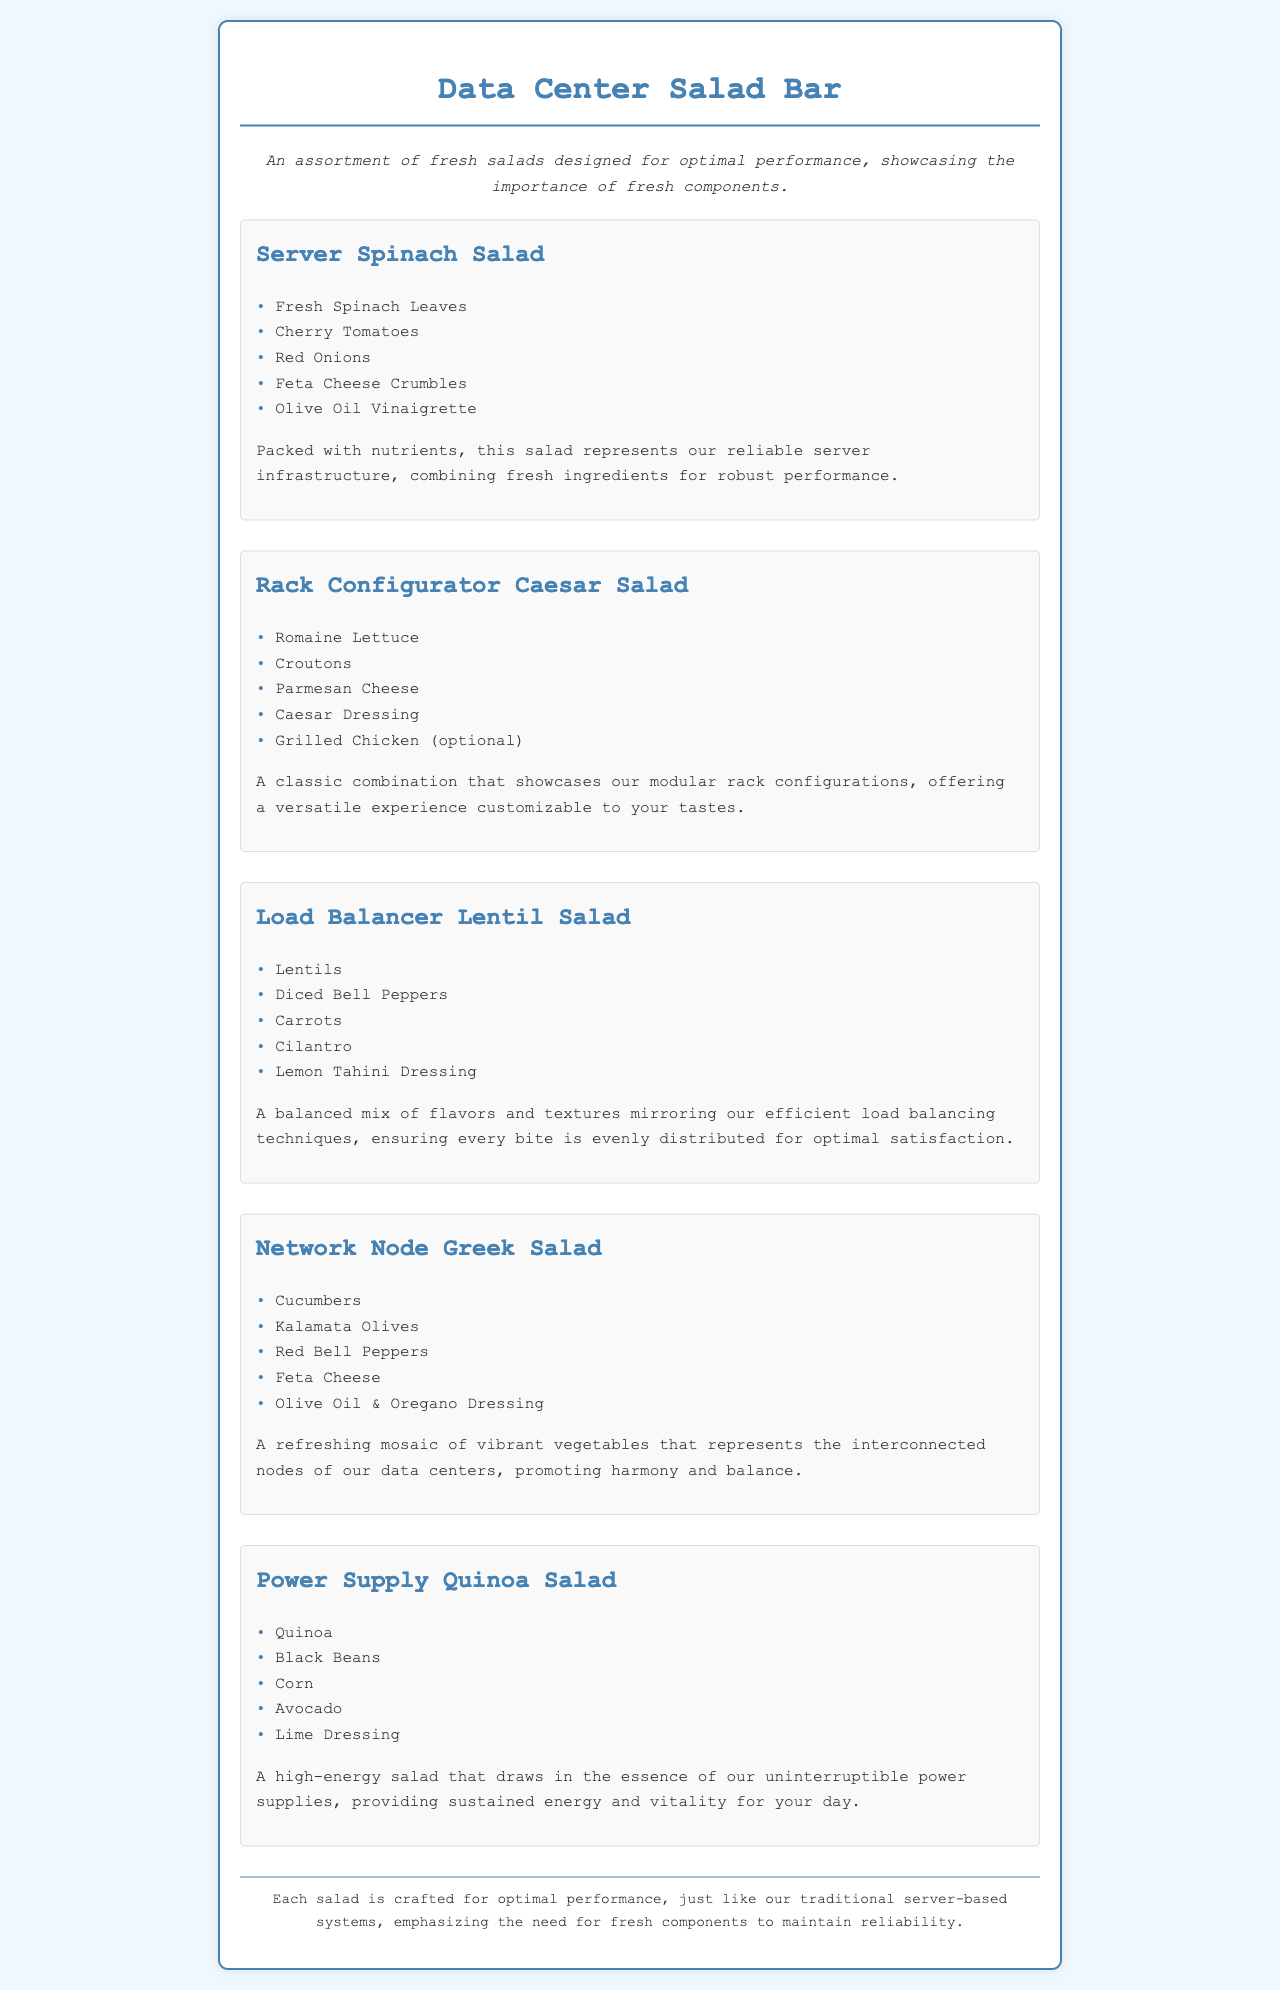What is the name of the first salad? The first salad listed in the document is the "Server Spinach Salad".
Answer: Server Spinach Salad How many salads are featured in the menu? The document includes a total of five salads.
Answer: Five What dressing is used in the Load Balancer Lentil Salad? The dressing mentioned for the Load Balancer Lentil Salad is Lemon Tahini Dressing.
Answer: Lemon Tahini Dressing Which salad has an optional ingredient? The salad with an optional ingredient is the "Rack Configurator Caesar Salad" where Grilled Chicken can be added.
Answer: Rack Configurator Caesar Salad What does the Power Supply Quinoa Salad symbolize? The Power Supply Quinoa Salad symbolizes uninterruptible power supplies providing sustained energy and vitality.
Answer: Uninterruptible power supplies Which salad includes feta cheese? The salads that include feta cheese are Server Spinach Salad and Network Node Greek Salad.
Answer: Server Spinach Salad, Network Node Greek Salad What is the primary vegetable in the Network Node Greek Salad? The primary vegetable featured in the Network Node Greek Salad is Cucumbers.
Answer: Cucumbers What is the color scheme of the document's title? The color scheme of the title features a blue color, indicated by the hex code for the text.
Answer: Blue 